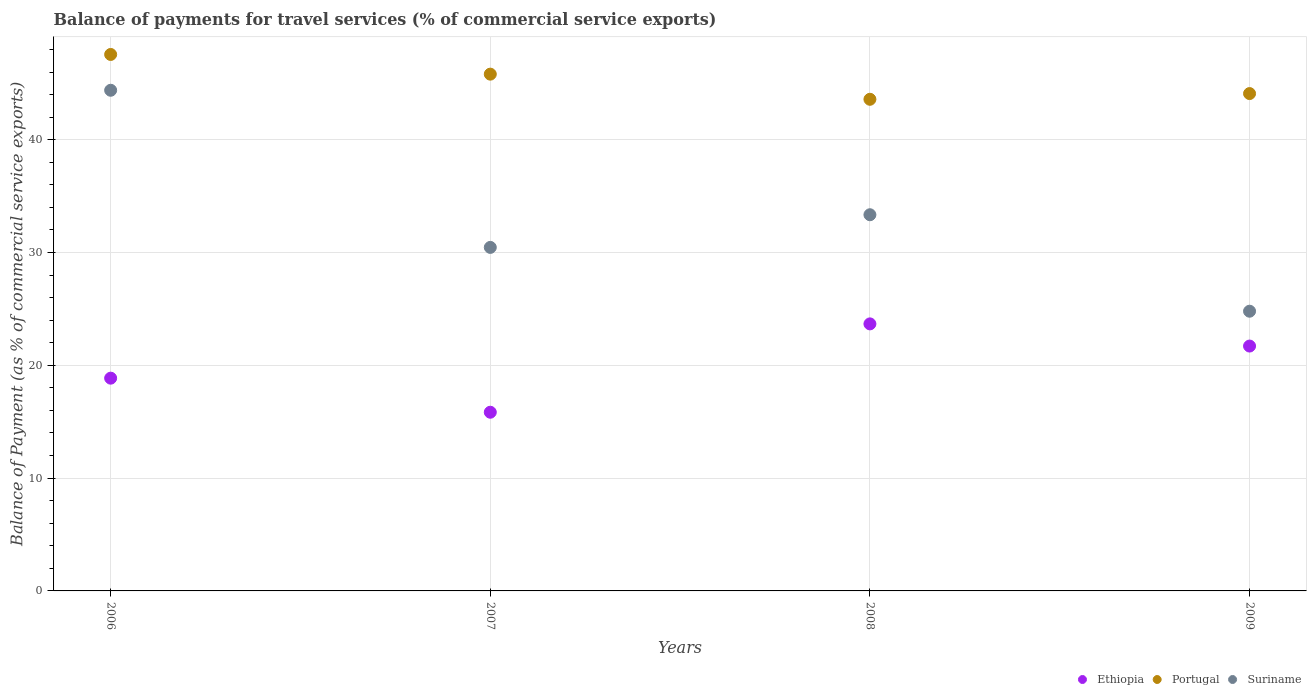Is the number of dotlines equal to the number of legend labels?
Your answer should be very brief. Yes. What is the balance of payments for travel services in Ethiopia in 2007?
Offer a very short reply. 15.84. Across all years, what is the maximum balance of payments for travel services in Suriname?
Make the answer very short. 44.38. Across all years, what is the minimum balance of payments for travel services in Portugal?
Provide a succinct answer. 43.58. In which year was the balance of payments for travel services in Ethiopia maximum?
Provide a succinct answer. 2008. In which year was the balance of payments for travel services in Suriname minimum?
Offer a terse response. 2009. What is the total balance of payments for travel services in Portugal in the graph?
Your response must be concise. 181.04. What is the difference between the balance of payments for travel services in Portugal in 2006 and that in 2009?
Your answer should be compact. 3.47. What is the difference between the balance of payments for travel services in Suriname in 2007 and the balance of payments for travel services in Portugal in 2009?
Provide a short and direct response. -13.64. What is the average balance of payments for travel services in Suriname per year?
Provide a short and direct response. 33.24. In the year 2008, what is the difference between the balance of payments for travel services in Portugal and balance of payments for travel services in Ethiopia?
Your answer should be compact. 19.91. In how many years, is the balance of payments for travel services in Ethiopia greater than 20 %?
Provide a short and direct response. 2. What is the ratio of the balance of payments for travel services in Suriname in 2008 to that in 2009?
Make the answer very short. 1.34. Is the balance of payments for travel services in Portugal in 2006 less than that in 2007?
Your answer should be very brief. No. What is the difference between the highest and the second highest balance of payments for travel services in Ethiopia?
Ensure brevity in your answer.  1.97. What is the difference between the highest and the lowest balance of payments for travel services in Portugal?
Provide a short and direct response. 3.97. In how many years, is the balance of payments for travel services in Ethiopia greater than the average balance of payments for travel services in Ethiopia taken over all years?
Offer a terse response. 2. Is it the case that in every year, the sum of the balance of payments for travel services in Ethiopia and balance of payments for travel services in Suriname  is greater than the balance of payments for travel services in Portugal?
Your response must be concise. Yes. Is the balance of payments for travel services in Portugal strictly greater than the balance of payments for travel services in Ethiopia over the years?
Provide a short and direct response. Yes. Is the balance of payments for travel services in Suriname strictly less than the balance of payments for travel services in Ethiopia over the years?
Offer a very short reply. No. How many years are there in the graph?
Ensure brevity in your answer.  4. Are the values on the major ticks of Y-axis written in scientific E-notation?
Your answer should be compact. No. Does the graph contain any zero values?
Keep it short and to the point. No. How are the legend labels stacked?
Your answer should be compact. Horizontal. What is the title of the graph?
Offer a terse response. Balance of payments for travel services (% of commercial service exports). Does "India" appear as one of the legend labels in the graph?
Your answer should be very brief. No. What is the label or title of the X-axis?
Provide a short and direct response. Years. What is the label or title of the Y-axis?
Offer a terse response. Balance of Payment (as % of commercial service exports). What is the Balance of Payment (as % of commercial service exports) of Ethiopia in 2006?
Offer a terse response. 18.86. What is the Balance of Payment (as % of commercial service exports) of Portugal in 2006?
Provide a short and direct response. 47.56. What is the Balance of Payment (as % of commercial service exports) of Suriname in 2006?
Offer a terse response. 44.38. What is the Balance of Payment (as % of commercial service exports) of Ethiopia in 2007?
Your answer should be very brief. 15.84. What is the Balance of Payment (as % of commercial service exports) of Portugal in 2007?
Make the answer very short. 45.81. What is the Balance of Payment (as % of commercial service exports) of Suriname in 2007?
Make the answer very short. 30.45. What is the Balance of Payment (as % of commercial service exports) in Ethiopia in 2008?
Provide a succinct answer. 23.67. What is the Balance of Payment (as % of commercial service exports) of Portugal in 2008?
Ensure brevity in your answer.  43.58. What is the Balance of Payment (as % of commercial service exports) in Suriname in 2008?
Your answer should be compact. 33.35. What is the Balance of Payment (as % of commercial service exports) of Ethiopia in 2009?
Offer a terse response. 21.71. What is the Balance of Payment (as % of commercial service exports) in Portugal in 2009?
Provide a short and direct response. 44.09. What is the Balance of Payment (as % of commercial service exports) of Suriname in 2009?
Keep it short and to the point. 24.8. Across all years, what is the maximum Balance of Payment (as % of commercial service exports) in Ethiopia?
Keep it short and to the point. 23.67. Across all years, what is the maximum Balance of Payment (as % of commercial service exports) of Portugal?
Make the answer very short. 47.56. Across all years, what is the maximum Balance of Payment (as % of commercial service exports) in Suriname?
Give a very brief answer. 44.38. Across all years, what is the minimum Balance of Payment (as % of commercial service exports) in Ethiopia?
Offer a very short reply. 15.84. Across all years, what is the minimum Balance of Payment (as % of commercial service exports) in Portugal?
Your response must be concise. 43.58. Across all years, what is the minimum Balance of Payment (as % of commercial service exports) in Suriname?
Give a very brief answer. 24.8. What is the total Balance of Payment (as % of commercial service exports) of Ethiopia in the graph?
Offer a terse response. 80.08. What is the total Balance of Payment (as % of commercial service exports) of Portugal in the graph?
Ensure brevity in your answer.  181.04. What is the total Balance of Payment (as % of commercial service exports) of Suriname in the graph?
Offer a terse response. 132.98. What is the difference between the Balance of Payment (as % of commercial service exports) in Ethiopia in 2006 and that in 2007?
Offer a very short reply. 3.02. What is the difference between the Balance of Payment (as % of commercial service exports) of Portugal in 2006 and that in 2007?
Keep it short and to the point. 1.75. What is the difference between the Balance of Payment (as % of commercial service exports) of Suriname in 2006 and that in 2007?
Offer a very short reply. 13.93. What is the difference between the Balance of Payment (as % of commercial service exports) of Ethiopia in 2006 and that in 2008?
Your answer should be compact. -4.81. What is the difference between the Balance of Payment (as % of commercial service exports) of Portugal in 2006 and that in 2008?
Your answer should be very brief. 3.97. What is the difference between the Balance of Payment (as % of commercial service exports) in Suriname in 2006 and that in 2008?
Give a very brief answer. 11.03. What is the difference between the Balance of Payment (as % of commercial service exports) in Ethiopia in 2006 and that in 2009?
Your answer should be very brief. -2.85. What is the difference between the Balance of Payment (as % of commercial service exports) in Portugal in 2006 and that in 2009?
Provide a short and direct response. 3.47. What is the difference between the Balance of Payment (as % of commercial service exports) in Suriname in 2006 and that in 2009?
Offer a terse response. 19.59. What is the difference between the Balance of Payment (as % of commercial service exports) in Ethiopia in 2007 and that in 2008?
Offer a terse response. -7.83. What is the difference between the Balance of Payment (as % of commercial service exports) of Portugal in 2007 and that in 2008?
Your answer should be compact. 2.23. What is the difference between the Balance of Payment (as % of commercial service exports) of Suriname in 2007 and that in 2008?
Offer a very short reply. -2.9. What is the difference between the Balance of Payment (as % of commercial service exports) of Ethiopia in 2007 and that in 2009?
Give a very brief answer. -5.87. What is the difference between the Balance of Payment (as % of commercial service exports) of Portugal in 2007 and that in 2009?
Give a very brief answer. 1.72. What is the difference between the Balance of Payment (as % of commercial service exports) in Suriname in 2007 and that in 2009?
Keep it short and to the point. 5.66. What is the difference between the Balance of Payment (as % of commercial service exports) in Ethiopia in 2008 and that in 2009?
Provide a succinct answer. 1.97. What is the difference between the Balance of Payment (as % of commercial service exports) in Portugal in 2008 and that in 2009?
Offer a very short reply. -0.51. What is the difference between the Balance of Payment (as % of commercial service exports) of Suriname in 2008 and that in 2009?
Make the answer very short. 8.55. What is the difference between the Balance of Payment (as % of commercial service exports) in Ethiopia in 2006 and the Balance of Payment (as % of commercial service exports) in Portugal in 2007?
Keep it short and to the point. -26.95. What is the difference between the Balance of Payment (as % of commercial service exports) of Ethiopia in 2006 and the Balance of Payment (as % of commercial service exports) of Suriname in 2007?
Your response must be concise. -11.59. What is the difference between the Balance of Payment (as % of commercial service exports) of Portugal in 2006 and the Balance of Payment (as % of commercial service exports) of Suriname in 2007?
Keep it short and to the point. 17.1. What is the difference between the Balance of Payment (as % of commercial service exports) of Ethiopia in 2006 and the Balance of Payment (as % of commercial service exports) of Portugal in 2008?
Give a very brief answer. -24.72. What is the difference between the Balance of Payment (as % of commercial service exports) in Ethiopia in 2006 and the Balance of Payment (as % of commercial service exports) in Suriname in 2008?
Your response must be concise. -14.49. What is the difference between the Balance of Payment (as % of commercial service exports) of Portugal in 2006 and the Balance of Payment (as % of commercial service exports) of Suriname in 2008?
Provide a short and direct response. 14.21. What is the difference between the Balance of Payment (as % of commercial service exports) in Ethiopia in 2006 and the Balance of Payment (as % of commercial service exports) in Portugal in 2009?
Your answer should be compact. -25.23. What is the difference between the Balance of Payment (as % of commercial service exports) of Ethiopia in 2006 and the Balance of Payment (as % of commercial service exports) of Suriname in 2009?
Offer a very short reply. -5.93. What is the difference between the Balance of Payment (as % of commercial service exports) in Portugal in 2006 and the Balance of Payment (as % of commercial service exports) in Suriname in 2009?
Ensure brevity in your answer.  22.76. What is the difference between the Balance of Payment (as % of commercial service exports) in Ethiopia in 2007 and the Balance of Payment (as % of commercial service exports) in Portugal in 2008?
Your answer should be compact. -27.74. What is the difference between the Balance of Payment (as % of commercial service exports) of Ethiopia in 2007 and the Balance of Payment (as % of commercial service exports) of Suriname in 2008?
Keep it short and to the point. -17.51. What is the difference between the Balance of Payment (as % of commercial service exports) of Portugal in 2007 and the Balance of Payment (as % of commercial service exports) of Suriname in 2008?
Your answer should be very brief. 12.46. What is the difference between the Balance of Payment (as % of commercial service exports) in Ethiopia in 2007 and the Balance of Payment (as % of commercial service exports) in Portugal in 2009?
Your response must be concise. -28.25. What is the difference between the Balance of Payment (as % of commercial service exports) in Ethiopia in 2007 and the Balance of Payment (as % of commercial service exports) in Suriname in 2009?
Keep it short and to the point. -8.96. What is the difference between the Balance of Payment (as % of commercial service exports) in Portugal in 2007 and the Balance of Payment (as % of commercial service exports) in Suriname in 2009?
Ensure brevity in your answer.  21.02. What is the difference between the Balance of Payment (as % of commercial service exports) in Ethiopia in 2008 and the Balance of Payment (as % of commercial service exports) in Portugal in 2009?
Ensure brevity in your answer.  -20.42. What is the difference between the Balance of Payment (as % of commercial service exports) in Ethiopia in 2008 and the Balance of Payment (as % of commercial service exports) in Suriname in 2009?
Give a very brief answer. -1.12. What is the difference between the Balance of Payment (as % of commercial service exports) of Portugal in 2008 and the Balance of Payment (as % of commercial service exports) of Suriname in 2009?
Provide a succinct answer. 18.79. What is the average Balance of Payment (as % of commercial service exports) in Ethiopia per year?
Ensure brevity in your answer.  20.02. What is the average Balance of Payment (as % of commercial service exports) in Portugal per year?
Provide a succinct answer. 45.26. What is the average Balance of Payment (as % of commercial service exports) of Suriname per year?
Keep it short and to the point. 33.24. In the year 2006, what is the difference between the Balance of Payment (as % of commercial service exports) of Ethiopia and Balance of Payment (as % of commercial service exports) of Portugal?
Offer a very short reply. -28.7. In the year 2006, what is the difference between the Balance of Payment (as % of commercial service exports) in Ethiopia and Balance of Payment (as % of commercial service exports) in Suriname?
Keep it short and to the point. -25.52. In the year 2006, what is the difference between the Balance of Payment (as % of commercial service exports) of Portugal and Balance of Payment (as % of commercial service exports) of Suriname?
Your answer should be very brief. 3.17. In the year 2007, what is the difference between the Balance of Payment (as % of commercial service exports) of Ethiopia and Balance of Payment (as % of commercial service exports) of Portugal?
Provide a succinct answer. -29.97. In the year 2007, what is the difference between the Balance of Payment (as % of commercial service exports) in Ethiopia and Balance of Payment (as % of commercial service exports) in Suriname?
Make the answer very short. -14.61. In the year 2007, what is the difference between the Balance of Payment (as % of commercial service exports) in Portugal and Balance of Payment (as % of commercial service exports) in Suriname?
Provide a short and direct response. 15.36. In the year 2008, what is the difference between the Balance of Payment (as % of commercial service exports) in Ethiopia and Balance of Payment (as % of commercial service exports) in Portugal?
Your answer should be very brief. -19.91. In the year 2008, what is the difference between the Balance of Payment (as % of commercial service exports) of Ethiopia and Balance of Payment (as % of commercial service exports) of Suriname?
Keep it short and to the point. -9.68. In the year 2008, what is the difference between the Balance of Payment (as % of commercial service exports) of Portugal and Balance of Payment (as % of commercial service exports) of Suriname?
Offer a very short reply. 10.23. In the year 2009, what is the difference between the Balance of Payment (as % of commercial service exports) in Ethiopia and Balance of Payment (as % of commercial service exports) in Portugal?
Provide a short and direct response. -22.38. In the year 2009, what is the difference between the Balance of Payment (as % of commercial service exports) of Ethiopia and Balance of Payment (as % of commercial service exports) of Suriname?
Offer a terse response. -3.09. In the year 2009, what is the difference between the Balance of Payment (as % of commercial service exports) of Portugal and Balance of Payment (as % of commercial service exports) of Suriname?
Make the answer very short. 19.29. What is the ratio of the Balance of Payment (as % of commercial service exports) in Ethiopia in 2006 to that in 2007?
Provide a succinct answer. 1.19. What is the ratio of the Balance of Payment (as % of commercial service exports) of Portugal in 2006 to that in 2007?
Your answer should be compact. 1.04. What is the ratio of the Balance of Payment (as % of commercial service exports) in Suriname in 2006 to that in 2007?
Offer a terse response. 1.46. What is the ratio of the Balance of Payment (as % of commercial service exports) of Ethiopia in 2006 to that in 2008?
Offer a very short reply. 0.8. What is the ratio of the Balance of Payment (as % of commercial service exports) of Portugal in 2006 to that in 2008?
Keep it short and to the point. 1.09. What is the ratio of the Balance of Payment (as % of commercial service exports) of Suriname in 2006 to that in 2008?
Your answer should be very brief. 1.33. What is the ratio of the Balance of Payment (as % of commercial service exports) in Ethiopia in 2006 to that in 2009?
Give a very brief answer. 0.87. What is the ratio of the Balance of Payment (as % of commercial service exports) in Portugal in 2006 to that in 2009?
Ensure brevity in your answer.  1.08. What is the ratio of the Balance of Payment (as % of commercial service exports) in Suriname in 2006 to that in 2009?
Provide a short and direct response. 1.79. What is the ratio of the Balance of Payment (as % of commercial service exports) in Ethiopia in 2007 to that in 2008?
Provide a short and direct response. 0.67. What is the ratio of the Balance of Payment (as % of commercial service exports) in Portugal in 2007 to that in 2008?
Offer a very short reply. 1.05. What is the ratio of the Balance of Payment (as % of commercial service exports) of Suriname in 2007 to that in 2008?
Your answer should be very brief. 0.91. What is the ratio of the Balance of Payment (as % of commercial service exports) in Ethiopia in 2007 to that in 2009?
Ensure brevity in your answer.  0.73. What is the ratio of the Balance of Payment (as % of commercial service exports) in Portugal in 2007 to that in 2009?
Your answer should be very brief. 1.04. What is the ratio of the Balance of Payment (as % of commercial service exports) of Suriname in 2007 to that in 2009?
Provide a succinct answer. 1.23. What is the ratio of the Balance of Payment (as % of commercial service exports) in Ethiopia in 2008 to that in 2009?
Ensure brevity in your answer.  1.09. What is the ratio of the Balance of Payment (as % of commercial service exports) of Suriname in 2008 to that in 2009?
Offer a terse response. 1.34. What is the difference between the highest and the second highest Balance of Payment (as % of commercial service exports) of Ethiopia?
Keep it short and to the point. 1.97. What is the difference between the highest and the second highest Balance of Payment (as % of commercial service exports) in Portugal?
Provide a short and direct response. 1.75. What is the difference between the highest and the second highest Balance of Payment (as % of commercial service exports) in Suriname?
Your answer should be compact. 11.03. What is the difference between the highest and the lowest Balance of Payment (as % of commercial service exports) of Ethiopia?
Your answer should be very brief. 7.83. What is the difference between the highest and the lowest Balance of Payment (as % of commercial service exports) in Portugal?
Ensure brevity in your answer.  3.97. What is the difference between the highest and the lowest Balance of Payment (as % of commercial service exports) in Suriname?
Provide a short and direct response. 19.59. 